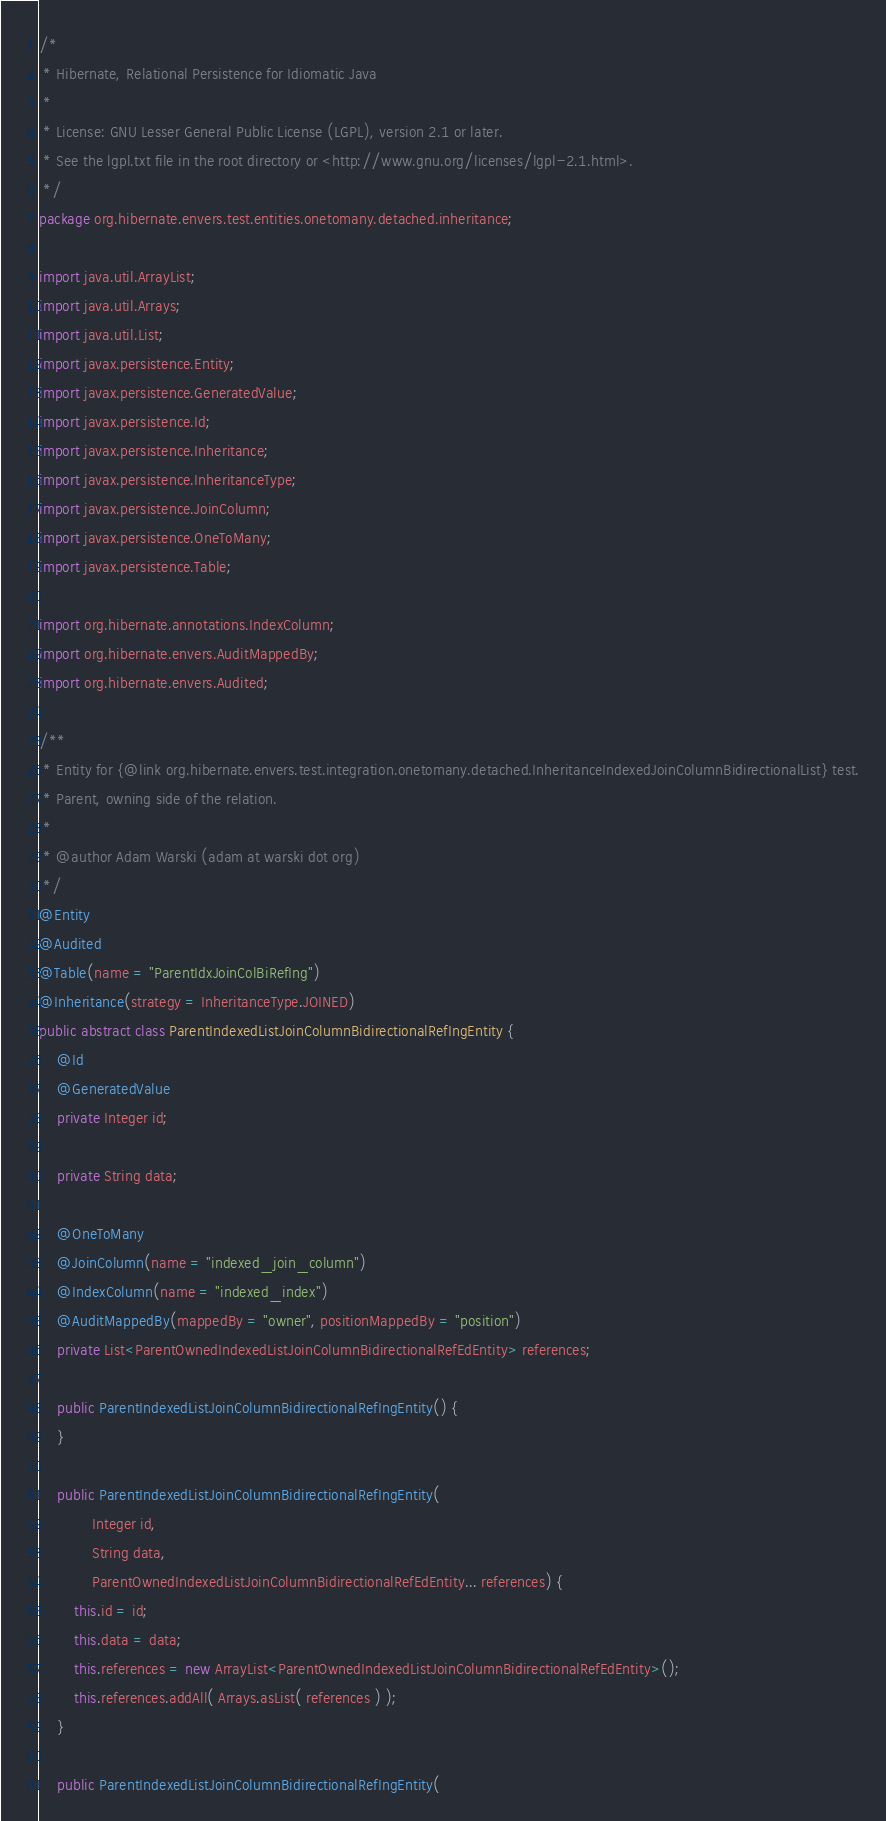<code> <loc_0><loc_0><loc_500><loc_500><_Java_>/*
 * Hibernate, Relational Persistence for Idiomatic Java
 *
 * License: GNU Lesser General Public License (LGPL), version 2.1 or later.
 * See the lgpl.txt file in the root directory or <http://www.gnu.org/licenses/lgpl-2.1.html>.
 */
package org.hibernate.envers.test.entities.onetomany.detached.inheritance;

import java.util.ArrayList;
import java.util.Arrays;
import java.util.List;
import javax.persistence.Entity;
import javax.persistence.GeneratedValue;
import javax.persistence.Id;
import javax.persistence.Inheritance;
import javax.persistence.InheritanceType;
import javax.persistence.JoinColumn;
import javax.persistence.OneToMany;
import javax.persistence.Table;

import org.hibernate.annotations.IndexColumn;
import org.hibernate.envers.AuditMappedBy;
import org.hibernate.envers.Audited;

/**
 * Entity for {@link org.hibernate.envers.test.integration.onetomany.detached.InheritanceIndexedJoinColumnBidirectionalList} test.
 * Parent, owning side of the relation.
 *
 * @author Adam Warski (adam at warski dot org)
 */
@Entity
@Audited
@Table(name = "ParentIdxJoinColBiRefIng")
@Inheritance(strategy = InheritanceType.JOINED)
public abstract class ParentIndexedListJoinColumnBidirectionalRefIngEntity {
	@Id
	@GeneratedValue
	private Integer id;

	private String data;

	@OneToMany
	@JoinColumn(name = "indexed_join_column")
	@IndexColumn(name = "indexed_index")
	@AuditMappedBy(mappedBy = "owner", positionMappedBy = "position")
	private List<ParentOwnedIndexedListJoinColumnBidirectionalRefEdEntity> references;

	public ParentIndexedListJoinColumnBidirectionalRefIngEntity() {
	}

	public ParentIndexedListJoinColumnBidirectionalRefIngEntity(
			Integer id,
			String data,
			ParentOwnedIndexedListJoinColumnBidirectionalRefEdEntity... references) {
		this.id = id;
		this.data = data;
		this.references = new ArrayList<ParentOwnedIndexedListJoinColumnBidirectionalRefEdEntity>();
		this.references.addAll( Arrays.asList( references ) );
	}

	public ParentIndexedListJoinColumnBidirectionalRefIngEntity(</code> 